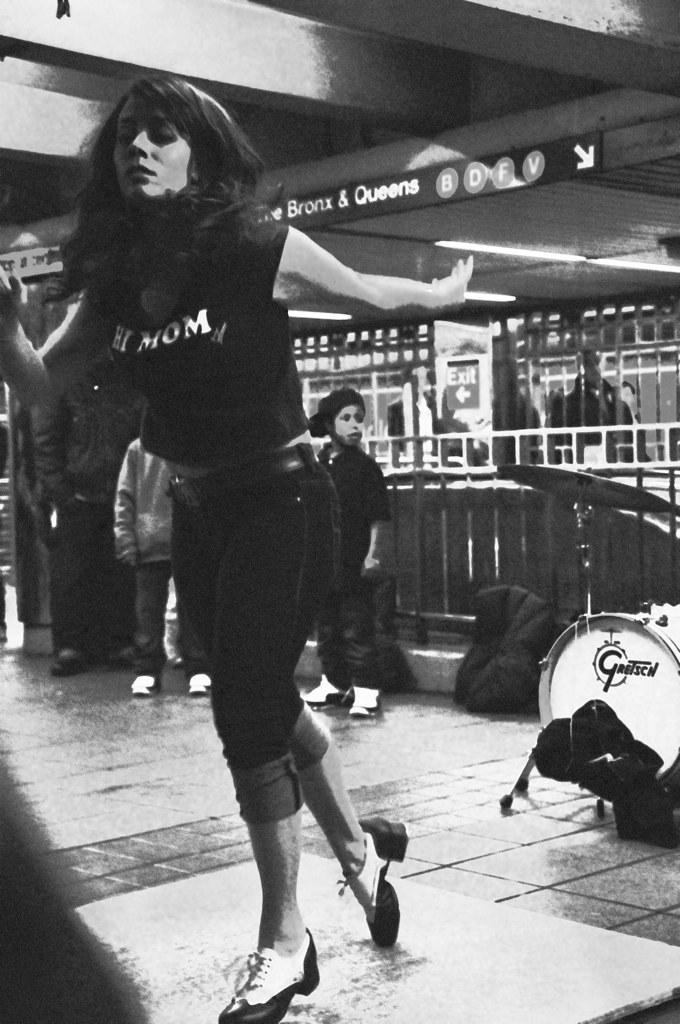What objects can be seen on the right side of the image? There are musical instruments on the right side of the image. Who is the main subject in the foreground of the image? There is a lady in the foreground of the image. What is the lady wearing? The lady is wearing a black t-shirt and black shorts. What can be seen in the background of the image? There is an exit sign in the background of the image. What additional information is provided by the exit sign? There is some text associated with the exit sign. What type of clover is the lady holding in the image? There is no clover present in the image; the lady is not holding any clover. What is the name of the musical piece being played by the instruments in the image? There is no indication of a specific musical piece being played in the image, so it cannot be determined from the image alone. 